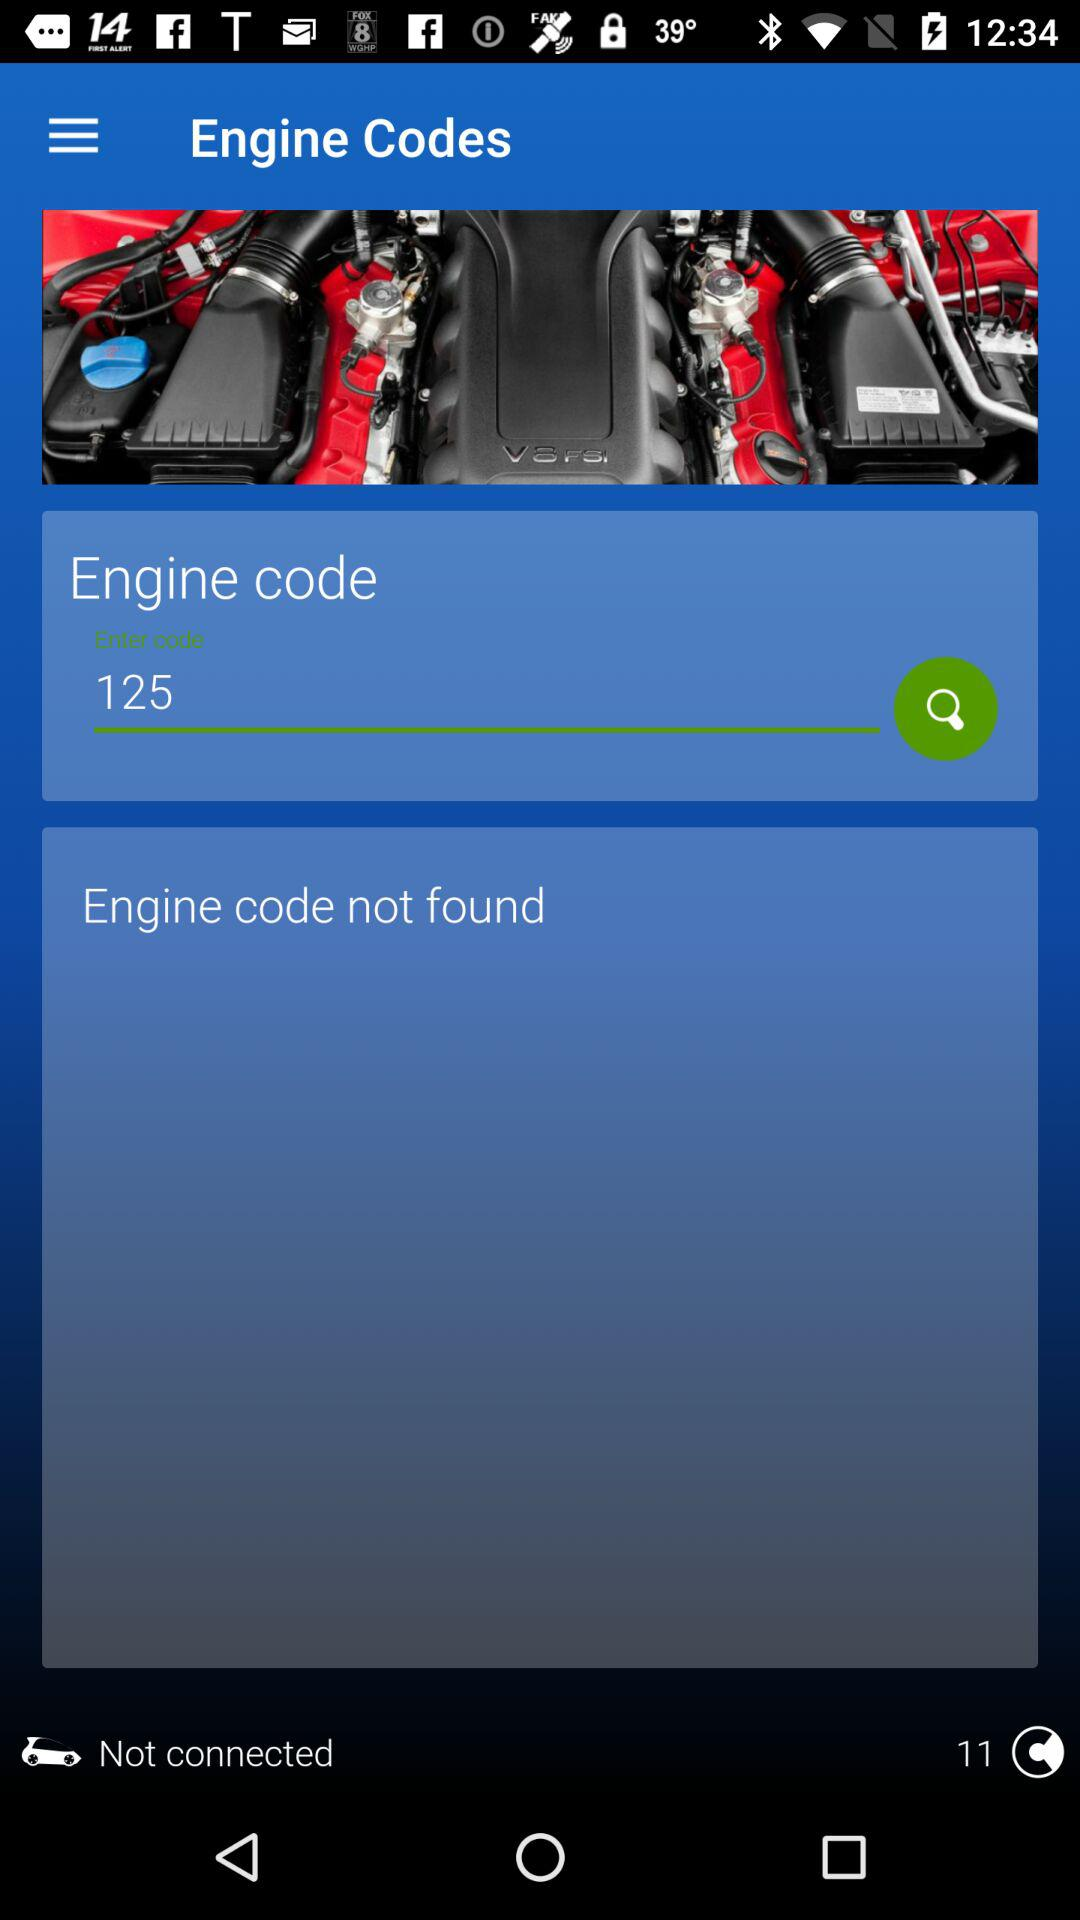What is the engine code? The engine code is "125". 